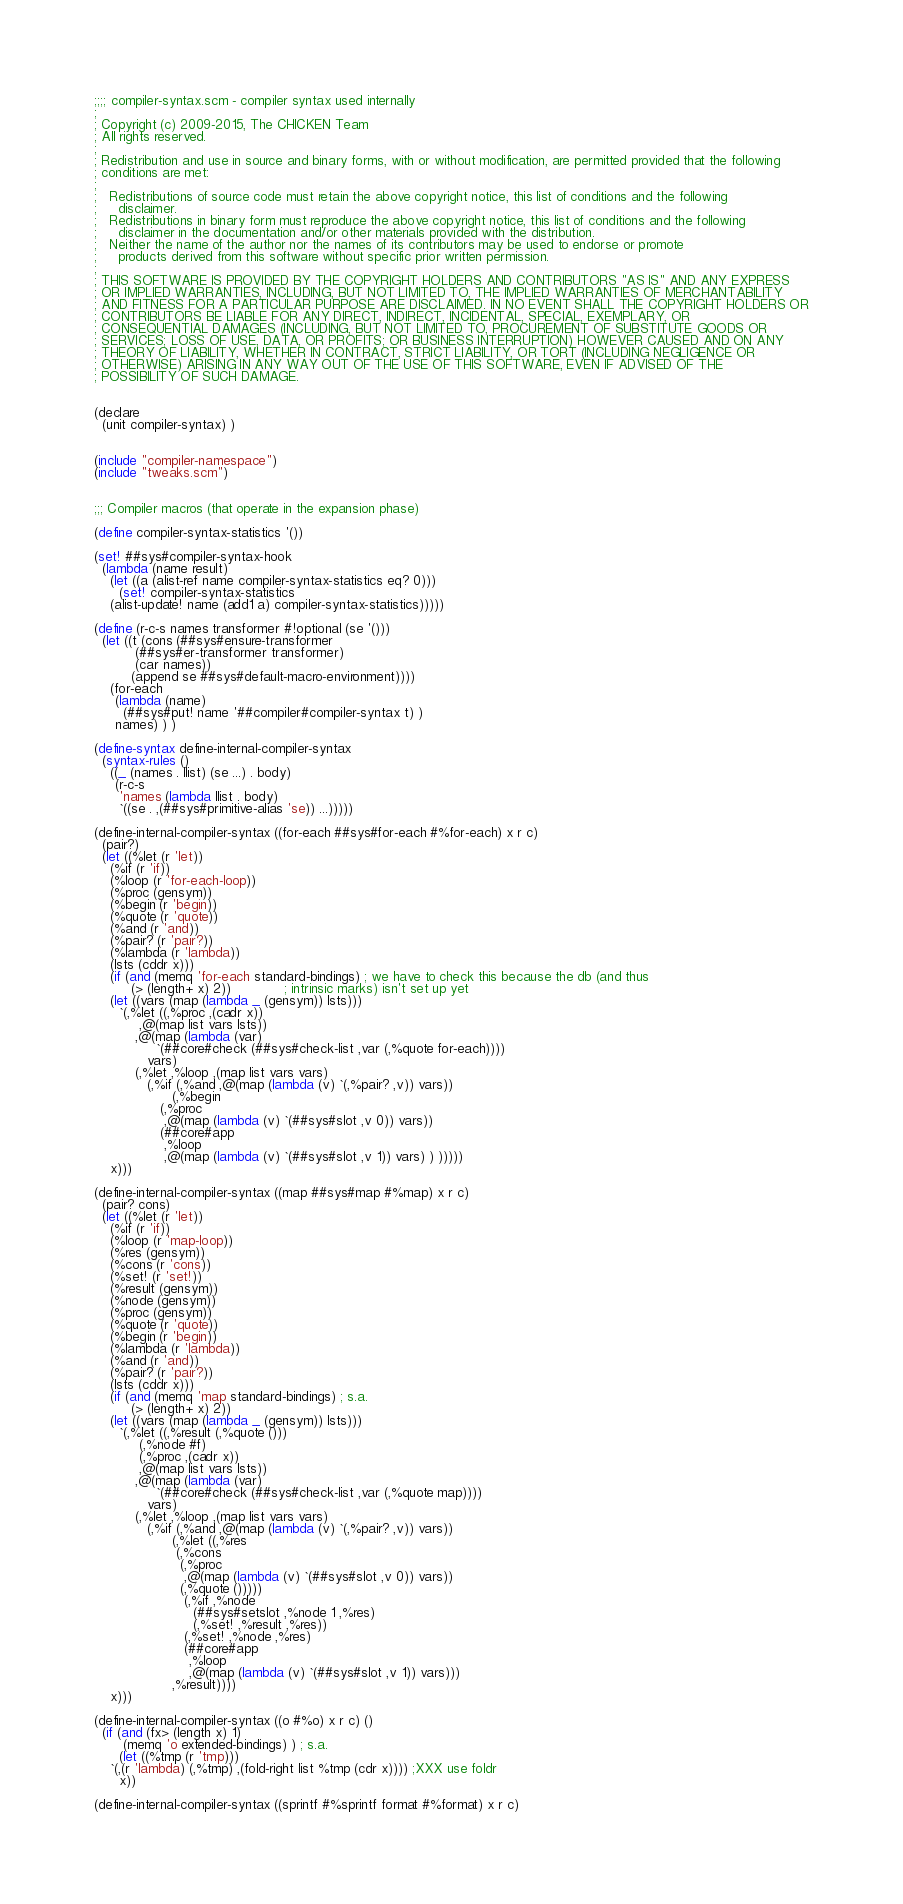Convert code to text. <code><loc_0><loc_0><loc_500><loc_500><_Scheme_>;;;; compiler-syntax.scm - compiler syntax used internally
;
; Copyright (c) 2009-2015, The CHICKEN Team
; All rights reserved.
;
; Redistribution and use in source and binary forms, with or without modification, are permitted provided that the following
; conditions are met:
;
;   Redistributions of source code must retain the above copyright notice, this list of conditions and the following
;     disclaimer. 
;   Redistributions in binary form must reproduce the above copyright notice, this list of conditions and the following
;     disclaimer in the documentation and/or other materials provided with the distribution. 
;   Neither the name of the author nor the names of its contributors may be used to endorse or promote
;     products derived from this software without specific prior written permission. 
;
; THIS SOFTWARE IS PROVIDED BY THE COPYRIGHT HOLDERS AND CONTRIBUTORS "AS IS" AND ANY EXPRESS
; OR IMPLIED WARRANTIES, INCLUDING, BUT NOT LIMITED TO, THE IMPLIED WARRANTIES OF MERCHANTABILITY
; AND FITNESS FOR A PARTICULAR PURPOSE ARE DISCLAIMED. IN NO EVENT SHALL THE COPYRIGHT HOLDERS OR
; CONTRIBUTORS BE LIABLE FOR ANY DIRECT, INDIRECT, INCIDENTAL, SPECIAL, EXEMPLARY, OR
; CONSEQUENTIAL DAMAGES (INCLUDING, BUT NOT LIMITED TO, PROCUREMENT OF SUBSTITUTE GOODS OR
; SERVICES; LOSS OF USE, DATA, OR PROFITS; OR BUSINESS INTERRUPTION) HOWEVER CAUSED AND ON ANY
; THEORY OF LIABILITY, WHETHER IN CONTRACT, STRICT LIABILITY, OR TORT (INCLUDING NEGLIGENCE OR
; OTHERWISE) ARISING IN ANY WAY OUT OF THE USE OF THIS SOFTWARE, EVEN IF ADVISED OF THE
; POSSIBILITY OF SUCH DAMAGE.


(declare 
  (unit compiler-syntax) )


(include "compiler-namespace")
(include "tweaks.scm")


;;; Compiler macros (that operate in the expansion phase)

(define compiler-syntax-statistics '())

(set! ##sys#compiler-syntax-hook
  (lambda (name result)
    (let ((a (alist-ref name compiler-syntax-statistics eq? 0)))
      (set! compiler-syntax-statistics
	(alist-update! name (add1 a) compiler-syntax-statistics)))))

(define (r-c-s names transformer #!optional (se '()))
  (let ((t (cons (##sys#ensure-transformer
		  (##sys#er-transformer transformer)
		  (car names))
		 (append se ##sys#default-macro-environment))))
    (for-each
     (lambda (name)
       (##sys#put! name '##compiler#compiler-syntax t) )
     names) ) )

(define-syntax define-internal-compiler-syntax
  (syntax-rules ()
    ((_ (names . llist) (se ...) . body)
     (r-c-s 
      'names (lambda llist . body) 
      `((se . ,(##sys#primitive-alias 'se)) ...)))))

(define-internal-compiler-syntax ((for-each ##sys#for-each #%for-each) x r c)
  (pair?)
  (let ((%let (r 'let))
	(%if (r 'if))
	(%loop (r 'for-each-loop))
	(%proc (gensym))
	(%begin (r 'begin))
	(%quote (r 'quote))
	(%and (r 'and))
	(%pair? (r 'pair?))
	(%lambda (r 'lambda))
	(lsts (cddr x)))
    (if (and (memq 'for-each standard-bindings) ; we have to check this because the db (and thus 
	     (> (length+ x) 2))			 ; intrinsic marks) isn't set up yet
	(let ((vars (map (lambda _ (gensym)) lsts)))
	  `(,%let ((,%proc ,(cadr x))
		   ,@(map list vars lsts))
		  ,@(map (lambda (var)
			   `(##core#check (##sys#check-list ,var (,%quote for-each))))
			 vars)
		  (,%let ,%loop ,(map list vars vars)
			 (,%if (,%and ,@(map (lambda (v) `(,%pair? ,v)) vars))
			       (,%begin
				(,%proc
				 ,@(map (lambda (v) `(##sys#slot ,v 0)) vars))
				(##core#app 
				 ,%loop
				 ,@(map (lambda (v) `(##sys#slot ,v 1)) vars) ) )))))
	x)))

(define-internal-compiler-syntax ((map ##sys#map #%map) x r c)
  (pair? cons)
  (let ((%let (r 'let))
	(%if (r 'if))
	(%loop (r 'map-loop))
	(%res (gensym))
	(%cons (r 'cons))
	(%set! (r 'set!))
	(%result (gensym))
	(%node (gensym))
	(%proc (gensym))
	(%quote (r 'quote))
	(%begin (r 'begin))
	(%lambda (r 'lambda))
	(%and (r 'and))
	(%pair? (r 'pair?))
	(lsts (cddr x)))
    (if (and (memq 'map standard-bindings) ; s.a.
	     (> (length+ x) 2))
	(let ((vars (map (lambda _ (gensym)) lsts)))
	  `(,%let ((,%result (,%quote ()))
		   (,%node #f)
		   (,%proc ,(cadr x))
		   ,@(map list vars lsts))		   
		  ,@(map (lambda (var)
			   `(##core#check (##sys#check-list ,var (,%quote map))))
			 vars)
		  (,%let ,%loop ,(map list vars vars)
			 (,%if (,%and ,@(map (lambda (v) `(,%pair? ,v)) vars))
			       (,%let ((,%res
					(,%cons
					 (,%proc
					  ,@(map (lambda (v) `(##sys#slot ,v 0)) vars))
					 (,%quote ()))))
				      (,%if ,%node
					    (##sys#setslot ,%node 1 ,%res)
					    (,%set! ,%result ,%res))
				      (,%set! ,%node ,%res)
				      (##core#app
				       ,%loop
				       ,@(map (lambda (v) `(##sys#slot ,v 1)) vars)))
			       ,%result))))
	x)))

(define-internal-compiler-syntax ((o #%o) x r c) ()
  (if (and (fx> (length x) 1)
	   (memq 'o extended-bindings) ) ; s.a.
      (let ((%tmp (r 'tmp)))
	`(,(r 'lambda) (,%tmp) ,(fold-right list %tmp (cdr x)))) ;XXX use foldr
      x))

(define-internal-compiler-syntax ((sprintf #%sprintf format #%format) x r c)</code> 